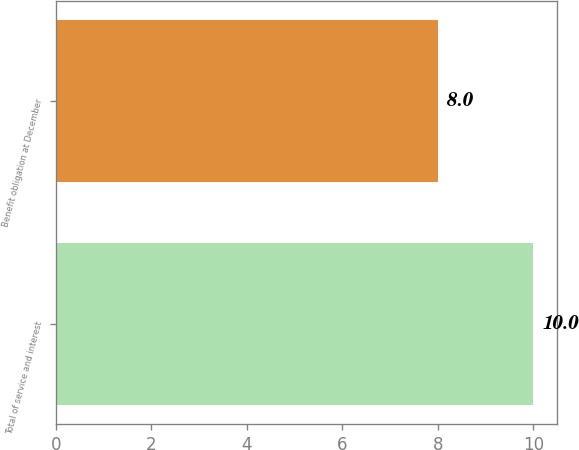<chart> <loc_0><loc_0><loc_500><loc_500><bar_chart><fcel>Total of service and interest<fcel>Benefit obligation at December<nl><fcel>10<fcel>8<nl></chart> 